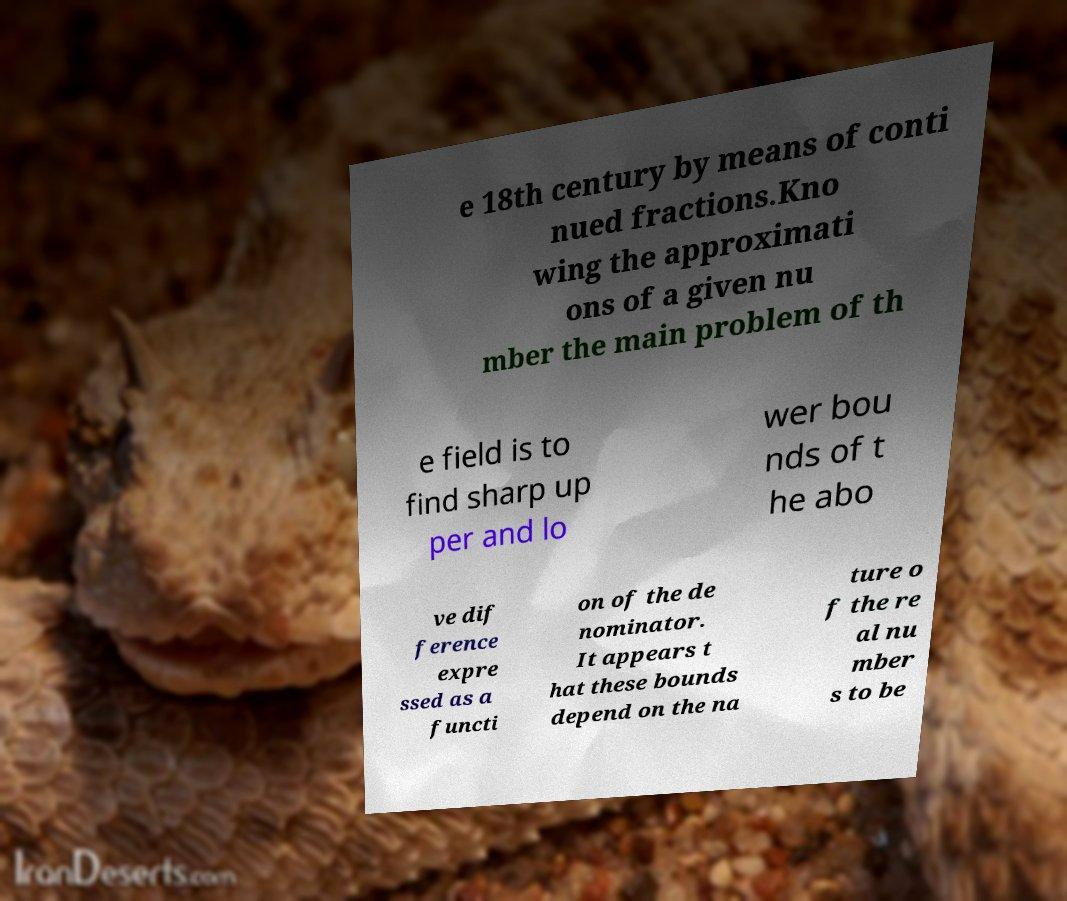Could you extract and type out the text from this image? e 18th century by means of conti nued fractions.Kno wing the approximati ons of a given nu mber the main problem of th e field is to find sharp up per and lo wer bou nds of t he abo ve dif ference expre ssed as a functi on of the de nominator. It appears t hat these bounds depend on the na ture o f the re al nu mber s to be 